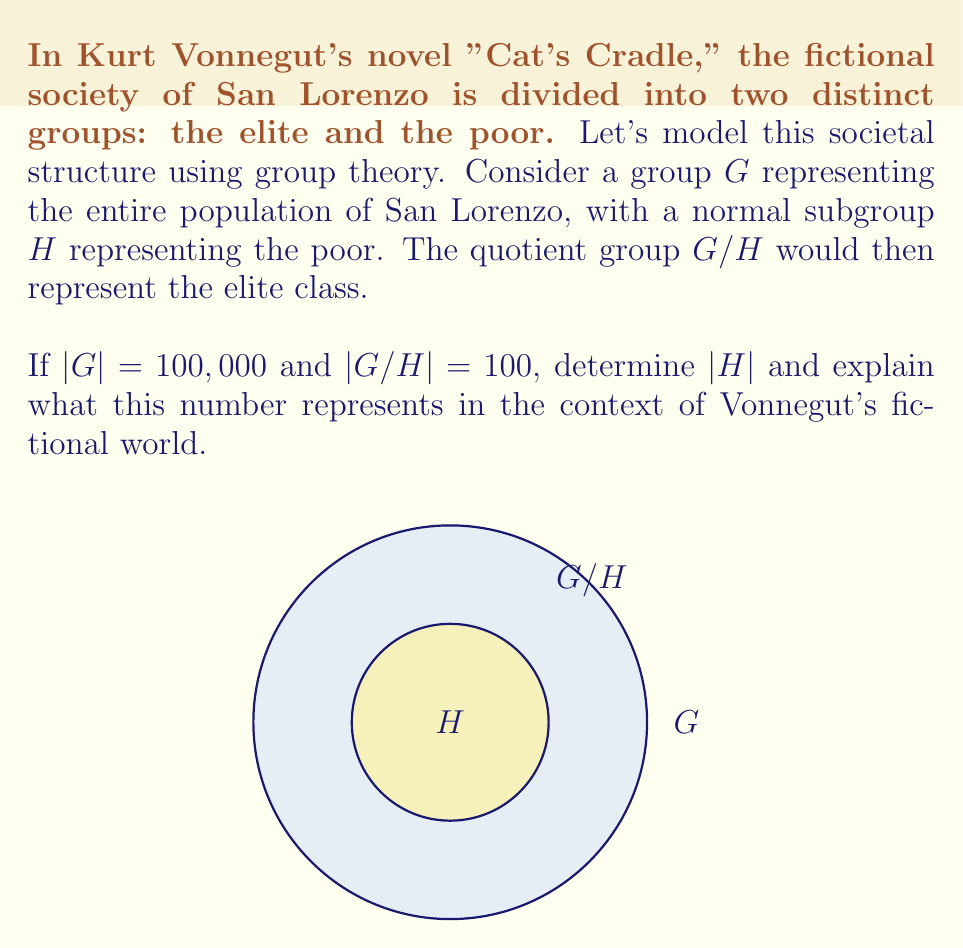Provide a solution to this math problem. To solve this problem, we'll use the fundamental theorem of quotient groups and interpret the result in the context of Vonnegut's fictional society.

Step 1: Recall the fundamental theorem of quotient groups
For a group $G$ and its normal subgroup $H$, we have:
$$|G| = |H| \cdot |G/H|$$

Step 2: Substitute the known values
We know that $|G| = 100,000$ and $|G/H| = 100$. Let's substitute these into our equation:
$$100,000 = |H| \cdot 100$$

Step 3: Solve for $|H|$
$$|H| = \frac{100,000}{100} = 1,000$$

Step 4: Interpret the result
In the context of Vonnegut's fictional world of San Lorenzo:
- $|G| = 100,000$ represents the total population of San Lorenzo
- $|G/H| = 100$ represents the number of people in the elite class
- $|H| = 1,000$ represents the number of people in each coset of $H$, which can be interpreted as the number of poor people "represented" by each member of the elite class

This mathematical model reflects Vonnegut's critique of social inequality, showing a stark 1:1000 ratio between the elite and the poor. It illustrates how group theory can be used to model and analyze societal structures in literature, providing a quantitative perspective on Vonnegut's themes of social stratification and power dynamics.
Answer: $|H| = 1,000$ 